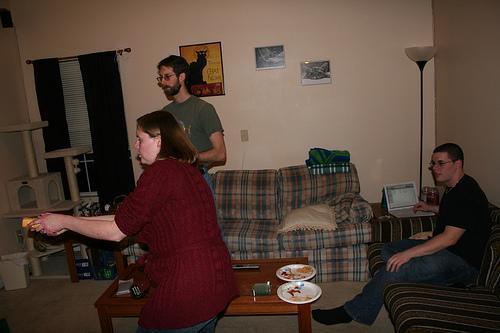How many couches are in the picture?
Give a very brief answer. 2. How many people are in the picture?
Give a very brief answer. 3. 